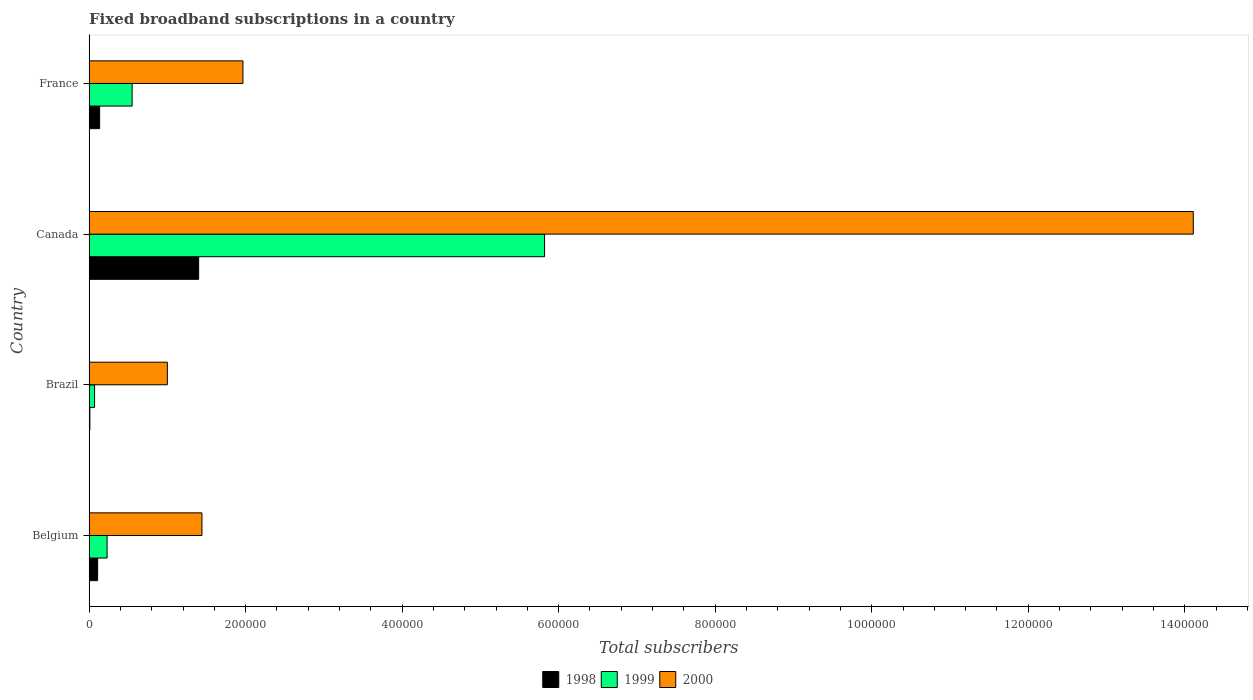How many groups of bars are there?
Offer a terse response. 4. Are the number of bars on each tick of the Y-axis equal?
Your answer should be compact. Yes. How many bars are there on the 2nd tick from the bottom?
Provide a short and direct response. 3. What is the label of the 4th group of bars from the top?
Give a very brief answer. Belgium. What is the number of broadband subscriptions in 1999 in Brazil?
Your answer should be very brief. 7000. Across all countries, what is the maximum number of broadband subscriptions in 2000?
Ensure brevity in your answer.  1.41e+06. Across all countries, what is the minimum number of broadband subscriptions in 2000?
Offer a very short reply. 1.00e+05. In which country was the number of broadband subscriptions in 2000 maximum?
Offer a very short reply. Canada. In which country was the number of broadband subscriptions in 1999 minimum?
Your answer should be compact. Brazil. What is the total number of broadband subscriptions in 2000 in the graph?
Your response must be concise. 1.85e+06. What is the difference between the number of broadband subscriptions in 1999 in Belgium and that in France?
Offer a terse response. -3.20e+04. What is the difference between the number of broadband subscriptions in 1999 in Brazil and the number of broadband subscriptions in 1998 in France?
Provide a succinct answer. -6464. What is the average number of broadband subscriptions in 1999 per country?
Your answer should be compact. 1.67e+05. What is the difference between the number of broadband subscriptions in 1999 and number of broadband subscriptions in 1998 in Canada?
Provide a succinct answer. 4.42e+05. In how many countries, is the number of broadband subscriptions in 2000 greater than 880000 ?
Your response must be concise. 1. What is the ratio of the number of broadband subscriptions in 1999 in Belgium to that in Canada?
Provide a short and direct response. 0.04. Is the number of broadband subscriptions in 1999 in Brazil less than that in France?
Keep it short and to the point. Yes. What is the difference between the highest and the second highest number of broadband subscriptions in 1999?
Ensure brevity in your answer.  5.27e+05. What is the difference between the highest and the lowest number of broadband subscriptions in 1998?
Make the answer very short. 1.39e+05. In how many countries, is the number of broadband subscriptions in 1998 greater than the average number of broadband subscriptions in 1998 taken over all countries?
Your answer should be compact. 1. What does the 3rd bar from the top in Canada represents?
Ensure brevity in your answer.  1998. What does the 2nd bar from the bottom in Canada represents?
Your response must be concise. 1999. Is it the case that in every country, the sum of the number of broadband subscriptions in 1998 and number of broadband subscriptions in 1999 is greater than the number of broadband subscriptions in 2000?
Your response must be concise. No. How many countries are there in the graph?
Offer a very short reply. 4. Does the graph contain any zero values?
Keep it short and to the point. No. Does the graph contain grids?
Ensure brevity in your answer.  No. How are the legend labels stacked?
Your answer should be compact. Horizontal. What is the title of the graph?
Offer a terse response. Fixed broadband subscriptions in a country. Does "1964" appear as one of the legend labels in the graph?
Offer a very short reply. No. What is the label or title of the X-axis?
Ensure brevity in your answer.  Total subscribers. What is the label or title of the Y-axis?
Make the answer very short. Country. What is the Total subscribers in 1998 in Belgium?
Keep it short and to the point. 1.09e+04. What is the Total subscribers in 1999 in Belgium?
Ensure brevity in your answer.  2.30e+04. What is the Total subscribers in 2000 in Belgium?
Your answer should be compact. 1.44e+05. What is the Total subscribers of 1999 in Brazil?
Give a very brief answer. 7000. What is the Total subscribers of 1999 in Canada?
Provide a short and direct response. 5.82e+05. What is the Total subscribers in 2000 in Canada?
Your answer should be compact. 1.41e+06. What is the Total subscribers of 1998 in France?
Your response must be concise. 1.35e+04. What is the Total subscribers of 1999 in France?
Provide a short and direct response. 5.50e+04. What is the Total subscribers in 2000 in France?
Give a very brief answer. 1.97e+05. Across all countries, what is the maximum Total subscribers in 1999?
Keep it short and to the point. 5.82e+05. Across all countries, what is the maximum Total subscribers in 2000?
Your response must be concise. 1.41e+06. Across all countries, what is the minimum Total subscribers in 1998?
Make the answer very short. 1000. Across all countries, what is the minimum Total subscribers in 1999?
Keep it short and to the point. 7000. Across all countries, what is the minimum Total subscribers of 2000?
Provide a short and direct response. 1.00e+05. What is the total Total subscribers in 1998 in the graph?
Offer a very short reply. 1.65e+05. What is the total Total subscribers of 1999 in the graph?
Offer a terse response. 6.67e+05. What is the total Total subscribers of 2000 in the graph?
Give a very brief answer. 1.85e+06. What is the difference between the Total subscribers in 1998 in Belgium and that in Brazil?
Keep it short and to the point. 9924. What is the difference between the Total subscribers in 1999 in Belgium and that in Brazil?
Your response must be concise. 1.60e+04. What is the difference between the Total subscribers of 2000 in Belgium and that in Brazil?
Provide a short and direct response. 4.42e+04. What is the difference between the Total subscribers of 1998 in Belgium and that in Canada?
Make the answer very short. -1.29e+05. What is the difference between the Total subscribers of 1999 in Belgium and that in Canada?
Keep it short and to the point. -5.59e+05. What is the difference between the Total subscribers of 2000 in Belgium and that in Canada?
Offer a very short reply. -1.27e+06. What is the difference between the Total subscribers of 1998 in Belgium and that in France?
Your answer should be very brief. -2540. What is the difference between the Total subscribers of 1999 in Belgium and that in France?
Offer a terse response. -3.20e+04. What is the difference between the Total subscribers in 2000 in Belgium and that in France?
Give a very brief answer. -5.24e+04. What is the difference between the Total subscribers of 1998 in Brazil and that in Canada?
Ensure brevity in your answer.  -1.39e+05. What is the difference between the Total subscribers of 1999 in Brazil and that in Canada?
Provide a short and direct response. -5.75e+05. What is the difference between the Total subscribers of 2000 in Brazil and that in Canada?
Your response must be concise. -1.31e+06. What is the difference between the Total subscribers in 1998 in Brazil and that in France?
Your answer should be very brief. -1.25e+04. What is the difference between the Total subscribers in 1999 in Brazil and that in France?
Offer a very short reply. -4.80e+04. What is the difference between the Total subscribers of 2000 in Brazil and that in France?
Offer a terse response. -9.66e+04. What is the difference between the Total subscribers in 1998 in Canada and that in France?
Ensure brevity in your answer.  1.27e+05. What is the difference between the Total subscribers of 1999 in Canada and that in France?
Give a very brief answer. 5.27e+05. What is the difference between the Total subscribers in 2000 in Canada and that in France?
Your answer should be very brief. 1.21e+06. What is the difference between the Total subscribers of 1998 in Belgium and the Total subscribers of 1999 in Brazil?
Your answer should be very brief. 3924. What is the difference between the Total subscribers in 1998 in Belgium and the Total subscribers in 2000 in Brazil?
Offer a terse response. -8.91e+04. What is the difference between the Total subscribers of 1999 in Belgium and the Total subscribers of 2000 in Brazil?
Provide a short and direct response. -7.70e+04. What is the difference between the Total subscribers in 1998 in Belgium and the Total subscribers in 1999 in Canada?
Provide a succinct answer. -5.71e+05. What is the difference between the Total subscribers in 1998 in Belgium and the Total subscribers in 2000 in Canada?
Offer a very short reply. -1.40e+06. What is the difference between the Total subscribers in 1999 in Belgium and the Total subscribers in 2000 in Canada?
Your answer should be compact. -1.39e+06. What is the difference between the Total subscribers in 1998 in Belgium and the Total subscribers in 1999 in France?
Make the answer very short. -4.41e+04. What is the difference between the Total subscribers in 1998 in Belgium and the Total subscribers in 2000 in France?
Offer a very short reply. -1.86e+05. What is the difference between the Total subscribers of 1999 in Belgium and the Total subscribers of 2000 in France?
Keep it short and to the point. -1.74e+05. What is the difference between the Total subscribers of 1998 in Brazil and the Total subscribers of 1999 in Canada?
Offer a very short reply. -5.81e+05. What is the difference between the Total subscribers in 1998 in Brazil and the Total subscribers in 2000 in Canada?
Provide a short and direct response. -1.41e+06. What is the difference between the Total subscribers in 1999 in Brazil and the Total subscribers in 2000 in Canada?
Keep it short and to the point. -1.40e+06. What is the difference between the Total subscribers of 1998 in Brazil and the Total subscribers of 1999 in France?
Offer a terse response. -5.40e+04. What is the difference between the Total subscribers of 1998 in Brazil and the Total subscribers of 2000 in France?
Offer a very short reply. -1.96e+05. What is the difference between the Total subscribers of 1999 in Brazil and the Total subscribers of 2000 in France?
Your answer should be very brief. -1.90e+05. What is the difference between the Total subscribers of 1998 in Canada and the Total subscribers of 1999 in France?
Your response must be concise. 8.50e+04. What is the difference between the Total subscribers of 1998 in Canada and the Total subscribers of 2000 in France?
Give a very brief answer. -5.66e+04. What is the difference between the Total subscribers in 1999 in Canada and the Total subscribers in 2000 in France?
Make the answer very short. 3.85e+05. What is the average Total subscribers of 1998 per country?
Keep it short and to the point. 4.13e+04. What is the average Total subscribers in 1999 per country?
Your response must be concise. 1.67e+05. What is the average Total subscribers in 2000 per country?
Keep it short and to the point. 4.63e+05. What is the difference between the Total subscribers of 1998 and Total subscribers of 1999 in Belgium?
Offer a terse response. -1.21e+04. What is the difference between the Total subscribers in 1998 and Total subscribers in 2000 in Belgium?
Give a very brief answer. -1.33e+05. What is the difference between the Total subscribers in 1999 and Total subscribers in 2000 in Belgium?
Offer a very short reply. -1.21e+05. What is the difference between the Total subscribers of 1998 and Total subscribers of 1999 in Brazil?
Give a very brief answer. -6000. What is the difference between the Total subscribers in 1998 and Total subscribers in 2000 in Brazil?
Your response must be concise. -9.90e+04. What is the difference between the Total subscribers of 1999 and Total subscribers of 2000 in Brazil?
Keep it short and to the point. -9.30e+04. What is the difference between the Total subscribers in 1998 and Total subscribers in 1999 in Canada?
Give a very brief answer. -4.42e+05. What is the difference between the Total subscribers in 1998 and Total subscribers in 2000 in Canada?
Keep it short and to the point. -1.27e+06. What is the difference between the Total subscribers in 1999 and Total subscribers in 2000 in Canada?
Give a very brief answer. -8.29e+05. What is the difference between the Total subscribers in 1998 and Total subscribers in 1999 in France?
Offer a very short reply. -4.15e+04. What is the difference between the Total subscribers of 1998 and Total subscribers of 2000 in France?
Give a very brief answer. -1.83e+05. What is the difference between the Total subscribers in 1999 and Total subscribers in 2000 in France?
Provide a short and direct response. -1.42e+05. What is the ratio of the Total subscribers of 1998 in Belgium to that in Brazil?
Your response must be concise. 10.92. What is the ratio of the Total subscribers in 1999 in Belgium to that in Brazil?
Keep it short and to the point. 3.29. What is the ratio of the Total subscribers in 2000 in Belgium to that in Brazil?
Offer a very short reply. 1.44. What is the ratio of the Total subscribers in 1998 in Belgium to that in Canada?
Keep it short and to the point. 0.08. What is the ratio of the Total subscribers in 1999 in Belgium to that in Canada?
Your answer should be very brief. 0.04. What is the ratio of the Total subscribers in 2000 in Belgium to that in Canada?
Keep it short and to the point. 0.1. What is the ratio of the Total subscribers in 1998 in Belgium to that in France?
Offer a very short reply. 0.81. What is the ratio of the Total subscribers of 1999 in Belgium to that in France?
Offer a very short reply. 0.42. What is the ratio of the Total subscribers in 2000 in Belgium to that in France?
Keep it short and to the point. 0.73. What is the ratio of the Total subscribers of 1998 in Brazil to that in Canada?
Your response must be concise. 0.01. What is the ratio of the Total subscribers in 1999 in Brazil to that in Canada?
Make the answer very short. 0.01. What is the ratio of the Total subscribers of 2000 in Brazil to that in Canada?
Your answer should be very brief. 0.07. What is the ratio of the Total subscribers of 1998 in Brazil to that in France?
Keep it short and to the point. 0.07. What is the ratio of the Total subscribers of 1999 in Brazil to that in France?
Your answer should be compact. 0.13. What is the ratio of the Total subscribers of 2000 in Brazil to that in France?
Your answer should be very brief. 0.51. What is the ratio of the Total subscribers in 1998 in Canada to that in France?
Your response must be concise. 10.4. What is the ratio of the Total subscribers of 1999 in Canada to that in France?
Offer a very short reply. 10.58. What is the ratio of the Total subscribers in 2000 in Canada to that in France?
Give a very brief answer. 7.18. What is the difference between the highest and the second highest Total subscribers in 1998?
Offer a terse response. 1.27e+05. What is the difference between the highest and the second highest Total subscribers of 1999?
Give a very brief answer. 5.27e+05. What is the difference between the highest and the second highest Total subscribers in 2000?
Give a very brief answer. 1.21e+06. What is the difference between the highest and the lowest Total subscribers in 1998?
Your response must be concise. 1.39e+05. What is the difference between the highest and the lowest Total subscribers in 1999?
Keep it short and to the point. 5.75e+05. What is the difference between the highest and the lowest Total subscribers in 2000?
Your answer should be very brief. 1.31e+06. 